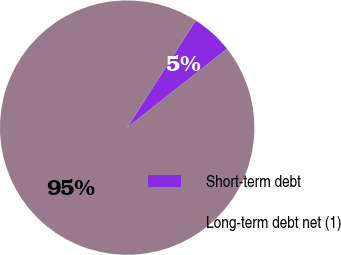Convert chart. <chart><loc_0><loc_0><loc_500><loc_500><pie_chart><fcel>Short-term debt<fcel>Long-term debt net (1)<nl><fcel>5.3%<fcel>94.7%<nl></chart> 